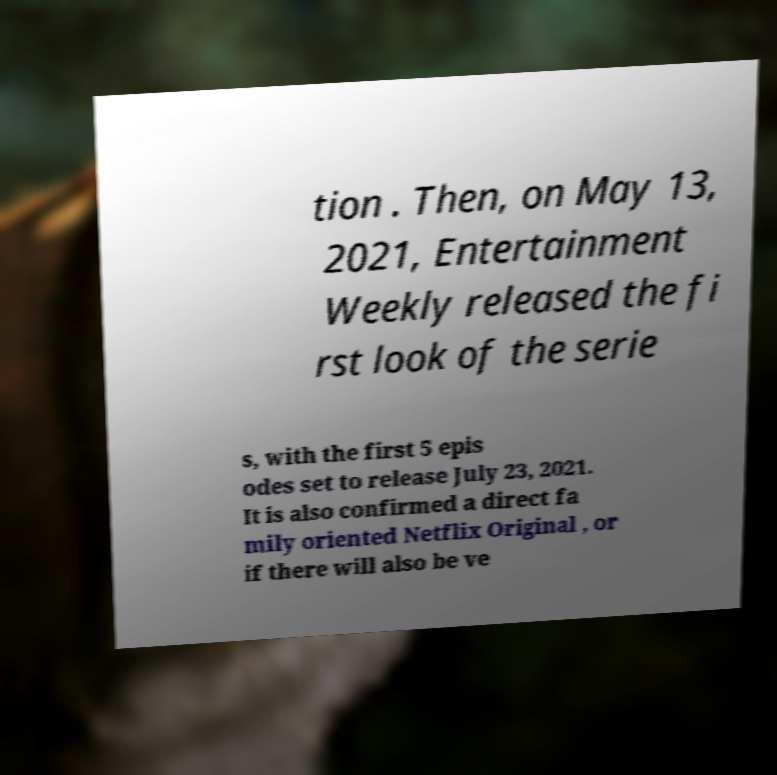For documentation purposes, I need the text within this image transcribed. Could you provide that? tion . Then, on May 13, 2021, Entertainment Weekly released the fi rst look of the serie s, with the first 5 epis odes set to release July 23, 2021. It is also confirmed a direct fa mily oriented Netflix Original , or if there will also be ve 